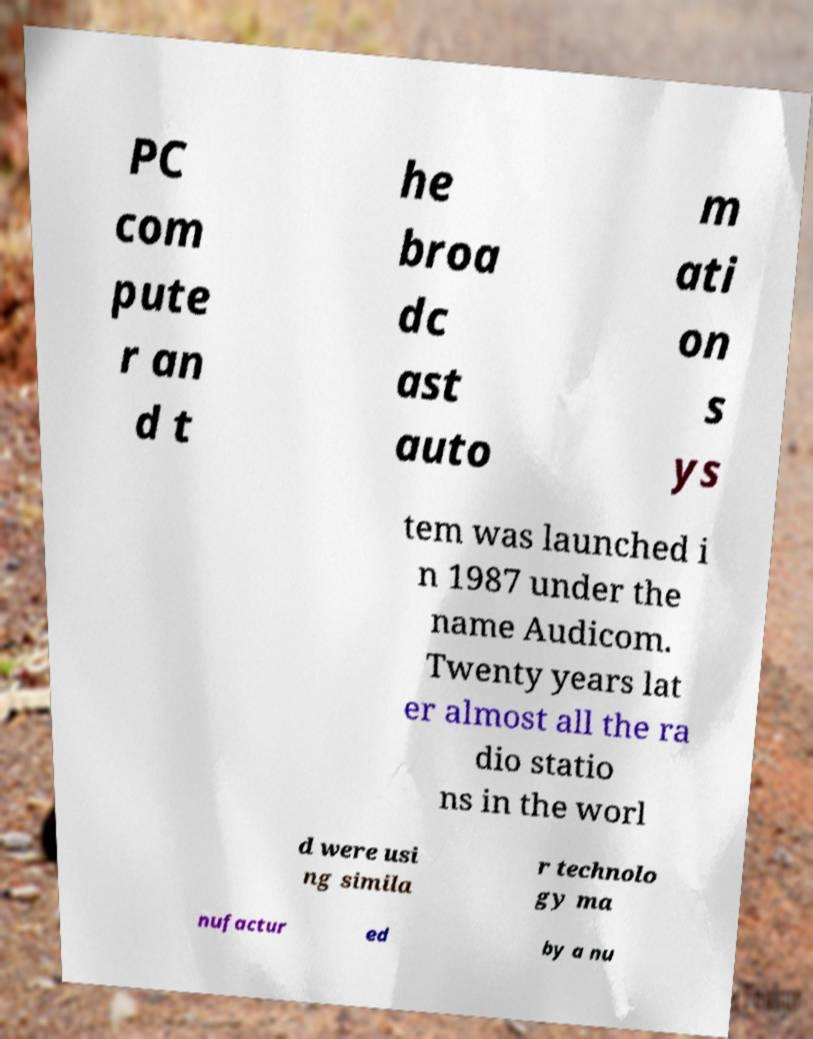Could you assist in decoding the text presented in this image and type it out clearly? PC com pute r an d t he broa dc ast auto m ati on s ys tem was launched i n 1987 under the name Audicom. Twenty years lat er almost all the ra dio statio ns in the worl d were usi ng simila r technolo gy ma nufactur ed by a nu 